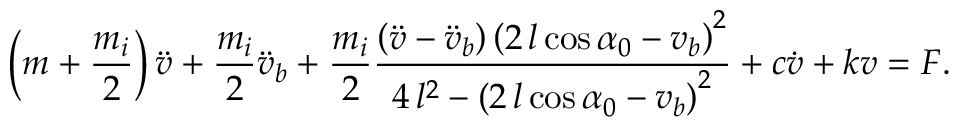Convert formula to latex. <formula><loc_0><loc_0><loc_500><loc_500>\left ( m + \frac { m _ { i } } { 2 } \right ) { \ddot { v } } + \frac { m _ { i } } { 2 } { \ddot { v } _ { b } } + \frac { m _ { i } } { 2 } \frac { \left ( \ddot { v } - \ddot { v } _ { b } \right ) \left ( 2 \, l \cos { \alpha _ { 0 } } - v _ { b } \right ) ^ { 2 } } { 4 \, l ^ { 2 } - { \left ( 2 \, l \cos { \alpha _ { 0 } } - v _ { b } \right ) } ^ { 2 } } + c \dot { v } + k v = F .</formula> 